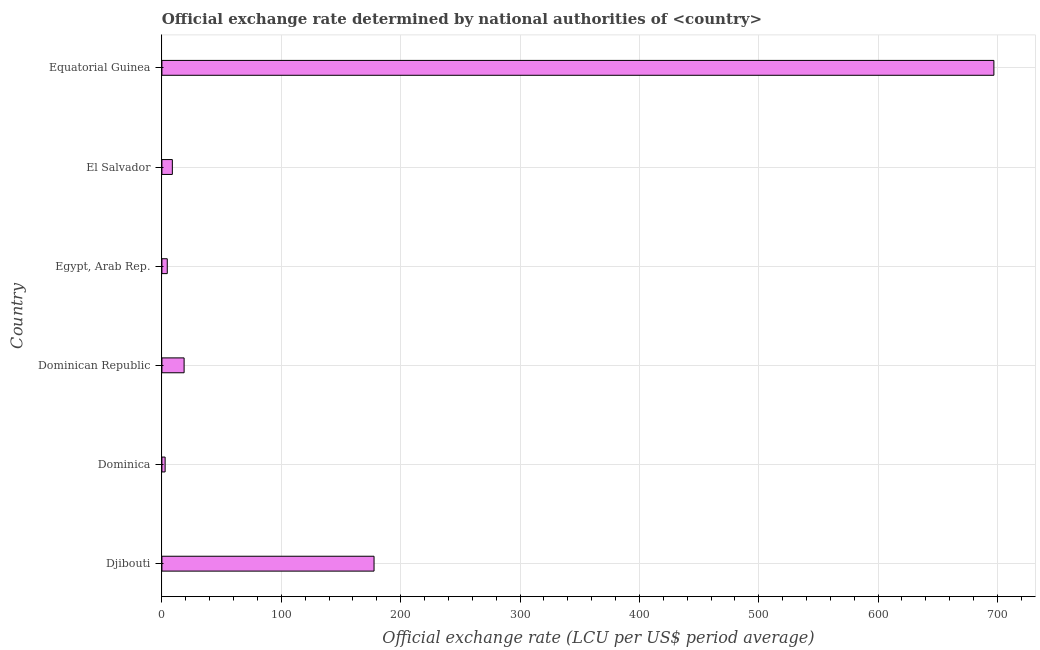Does the graph contain any zero values?
Your response must be concise. No. Does the graph contain grids?
Keep it short and to the point. Yes. What is the title of the graph?
Give a very brief answer. Official exchange rate determined by national authorities of <country>. What is the label or title of the X-axis?
Offer a terse response. Official exchange rate (LCU per US$ period average). What is the official exchange rate in Egypt, Arab Rep.?
Ensure brevity in your answer.  4.5. Across all countries, what is the maximum official exchange rate?
Keep it short and to the point. 696.99. In which country was the official exchange rate maximum?
Provide a succinct answer. Equatorial Guinea. In which country was the official exchange rate minimum?
Ensure brevity in your answer.  Dominica. What is the sum of the official exchange rate?
Offer a very short reply. 909.27. What is the difference between the official exchange rate in Dominica and Equatorial Guinea?
Make the answer very short. -694.29. What is the average official exchange rate per country?
Ensure brevity in your answer.  151.54. What is the median official exchange rate?
Your response must be concise. 13.68. In how many countries, is the official exchange rate greater than 20 ?
Offer a very short reply. 2. What is the ratio of the official exchange rate in Dominican Republic to that in Equatorial Guinea?
Make the answer very short. 0.03. What is the difference between the highest and the second highest official exchange rate?
Provide a succinct answer. 519.27. Is the sum of the official exchange rate in El Salvador and Equatorial Guinea greater than the maximum official exchange rate across all countries?
Give a very brief answer. Yes. What is the difference between the highest and the lowest official exchange rate?
Provide a succinct answer. 694.29. In how many countries, is the official exchange rate greater than the average official exchange rate taken over all countries?
Your response must be concise. 2. How many bars are there?
Offer a very short reply. 6. How many countries are there in the graph?
Keep it short and to the point. 6. What is the difference between two consecutive major ticks on the X-axis?
Offer a very short reply. 100. What is the Official exchange rate (LCU per US$ period average) in Djibouti?
Your answer should be very brief. 177.72. What is the Official exchange rate (LCU per US$ period average) in Dominica?
Keep it short and to the point. 2.7. What is the Official exchange rate (LCU per US$ period average) in Dominican Republic?
Give a very brief answer. 18.61. What is the Official exchange rate (LCU per US$ period average) of Egypt, Arab Rep.?
Your answer should be very brief. 4.5. What is the Official exchange rate (LCU per US$ period average) of El Salvador?
Keep it short and to the point. 8.75. What is the Official exchange rate (LCU per US$ period average) in Equatorial Guinea?
Give a very brief answer. 696.99. What is the difference between the Official exchange rate (LCU per US$ period average) in Djibouti and Dominica?
Offer a very short reply. 175.02. What is the difference between the Official exchange rate (LCU per US$ period average) in Djibouti and Dominican Republic?
Your answer should be very brief. 159.11. What is the difference between the Official exchange rate (LCU per US$ period average) in Djibouti and Egypt, Arab Rep.?
Your response must be concise. 173.22. What is the difference between the Official exchange rate (LCU per US$ period average) in Djibouti and El Salvador?
Give a very brief answer. 168.97. What is the difference between the Official exchange rate (LCU per US$ period average) in Djibouti and Equatorial Guinea?
Offer a very short reply. -519.27. What is the difference between the Official exchange rate (LCU per US$ period average) in Dominica and Dominican Republic?
Keep it short and to the point. -15.91. What is the difference between the Official exchange rate (LCU per US$ period average) in Dominica and Egypt, Arab Rep.?
Ensure brevity in your answer.  -1.8. What is the difference between the Official exchange rate (LCU per US$ period average) in Dominica and El Salvador?
Make the answer very short. -6.05. What is the difference between the Official exchange rate (LCU per US$ period average) in Dominica and Equatorial Guinea?
Provide a short and direct response. -694.29. What is the difference between the Official exchange rate (LCU per US$ period average) in Dominican Republic and Egypt, Arab Rep.?
Ensure brevity in your answer.  14.11. What is the difference between the Official exchange rate (LCU per US$ period average) in Dominican Republic and El Salvador?
Provide a short and direct response. 9.86. What is the difference between the Official exchange rate (LCU per US$ period average) in Dominican Republic and Equatorial Guinea?
Provide a short and direct response. -678.38. What is the difference between the Official exchange rate (LCU per US$ period average) in Egypt, Arab Rep. and El Salvador?
Your answer should be very brief. -4.25. What is the difference between the Official exchange rate (LCU per US$ period average) in Egypt, Arab Rep. and Equatorial Guinea?
Give a very brief answer. -692.49. What is the difference between the Official exchange rate (LCU per US$ period average) in El Salvador and Equatorial Guinea?
Give a very brief answer. -688.24. What is the ratio of the Official exchange rate (LCU per US$ period average) in Djibouti to that in Dominica?
Give a very brief answer. 65.82. What is the ratio of the Official exchange rate (LCU per US$ period average) in Djibouti to that in Dominican Republic?
Provide a short and direct response. 9.55. What is the ratio of the Official exchange rate (LCU per US$ period average) in Djibouti to that in Egypt, Arab Rep.?
Your answer should be compact. 39.5. What is the ratio of the Official exchange rate (LCU per US$ period average) in Djibouti to that in El Salvador?
Provide a succinct answer. 20.31. What is the ratio of the Official exchange rate (LCU per US$ period average) in Djibouti to that in Equatorial Guinea?
Your answer should be very brief. 0.26. What is the ratio of the Official exchange rate (LCU per US$ period average) in Dominica to that in Dominican Republic?
Give a very brief answer. 0.14. What is the ratio of the Official exchange rate (LCU per US$ period average) in Dominica to that in El Salvador?
Your answer should be compact. 0.31. What is the ratio of the Official exchange rate (LCU per US$ period average) in Dominica to that in Equatorial Guinea?
Your answer should be compact. 0. What is the ratio of the Official exchange rate (LCU per US$ period average) in Dominican Republic to that in Egypt, Arab Rep.?
Provide a short and direct response. 4.14. What is the ratio of the Official exchange rate (LCU per US$ period average) in Dominican Republic to that in El Salvador?
Make the answer very short. 2.13. What is the ratio of the Official exchange rate (LCU per US$ period average) in Dominican Republic to that in Equatorial Guinea?
Your answer should be very brief. 0.03. What is the ratio of the Official exchange rate (LCU per US$ period average) in Egypt, Arab Rep. to that in El Salvador?
Keep it short and to the point. 0.51. What is the ratio of the Official exchange rate (LCU per US$ period average) in Egypt, Arab Rep. to that in Equatorial Guinea?
Give a very brief answer. 0.01. What is the ratio of the Official exchange rate (LCU per US$ period average) in El Salvador to that in Equatorial Guinea?
Keep it short and to the point. 0.01. 